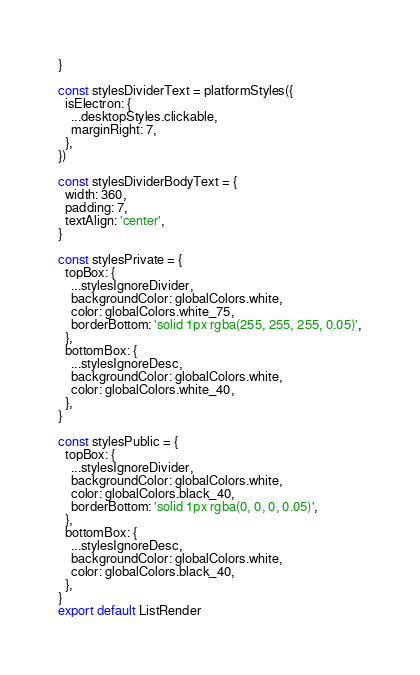<code> <loc_0><loc_0><loc_500><loc_500><_JavaScript_>}

const stylesDividerText = platformStyles({
  isElectron: {
    ...desktopStyles.clickable,
    marginRight: 7,
  },
})

const stylesDividerBodyText = {
  width: 360,
  padding: 7,
  textAlign: 'center',
}

const stylesPrivate = {
  topBox: {
    ...stylesIgnoreDivider,
    backgroundColor: globalColors.white,
    color: globalColors.white_75,
    borderBottom: 'solid 1px rgba(255, 255, 255, 0.05)',
  },
  bottomBox: {
    ...stylesIgnoreDesc,
    backgroundColor: globalColors.white,
    color: globalColors.white_40,
  },
}

const stylesPublic = {
  topBox: {
    ...stylesIgnoreDivider,
    backgroundColor: globalColors.white,
    color: globalColors.black_40,
    borderBottom: 'solid 1px rgba(0, 0, 0, 0.05)',
  },
  bottomBox: {
    ...stylesIgnoreDesc,
    backgroundColor: globalColors.white,
    color: globalColors.black_40,
  },
}
export default ListRender
</code> 